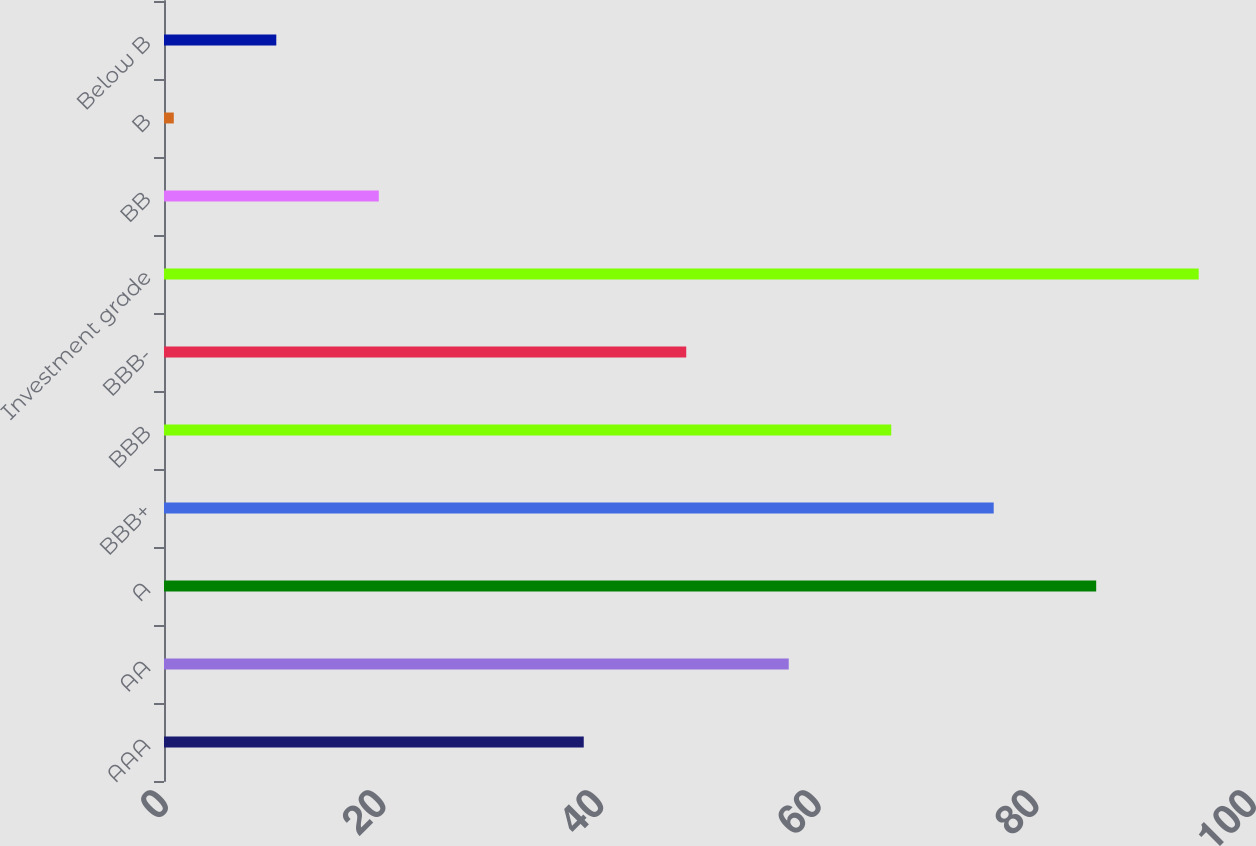Convert chart. <chart><loc_0><loc_0><loc_500><loc_500><bar_chart><fcel>AAA<fcel>AA<fcel>A<fcel>BBB+<fcel>BBB<fcel>BBB-<fcel>Investment grade<fcel>BB<fcel>B<fcel>Below B<nl><fcel>38.58<fcel>57.42<fcel>85.68<fcel>76.26<fcel>66.84<fcel>48<fcel>95.1<fcel>19.74<fcel>0.9<fcel>10.32<nl></chart> 